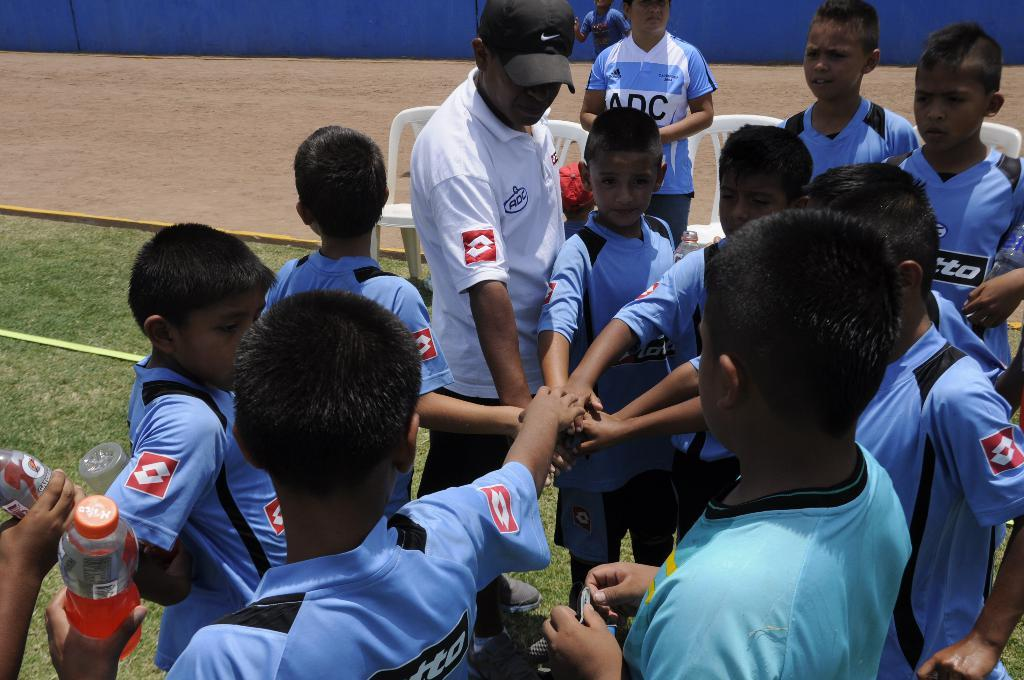What are the people in the image doing? The people in the image are standing on the grass. What type of surface can be seen in the image besides the grass? There is sand visible in the image. What type of furniture is present in the image? There are sitting chairs in the image. What items might be used for hydration in the image? Water bottles are present in the image. What type of lace is used to decorate the oven in the image? There is no oven present in the image, and therefore no lace can be observed. 